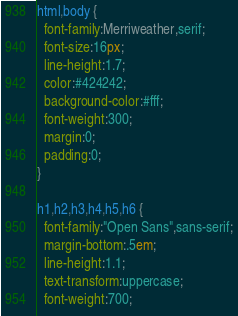<code> <loc_0><loc_0><loc_500><loc_500><_CSS_>html,body {
  font-family:Merriweather,serif;
  font-size:16px;
  line-height:1.7;
  color:#424242;
  background-color:#fff;
  font-weight:300;
  margin:0;
  padding:0;
}

h1,h2,h3,h4,h5,h6 {
  font-family:"Open Sans",sans-serif;
  margin-bottom:.5em;
  line-height:1.1;
  text-transform:uppercase;
  font-weight:700;</code> 